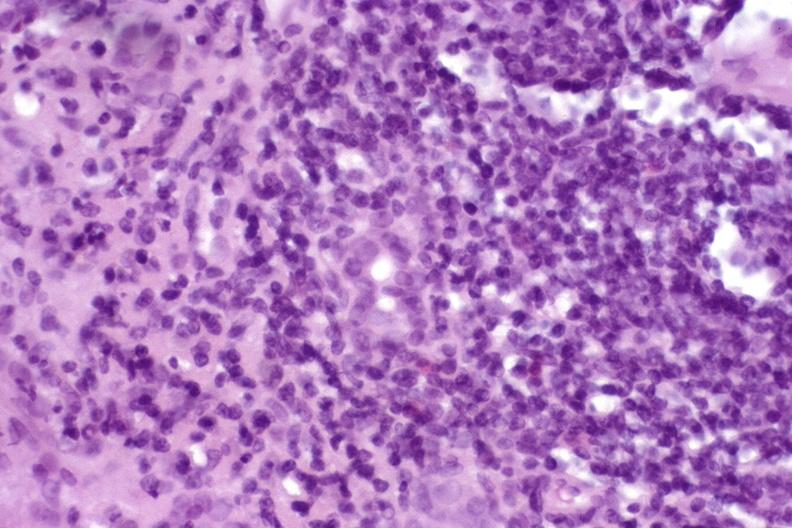s hepatobiliary present?
Answer the question using a single word or phrase. Yes 